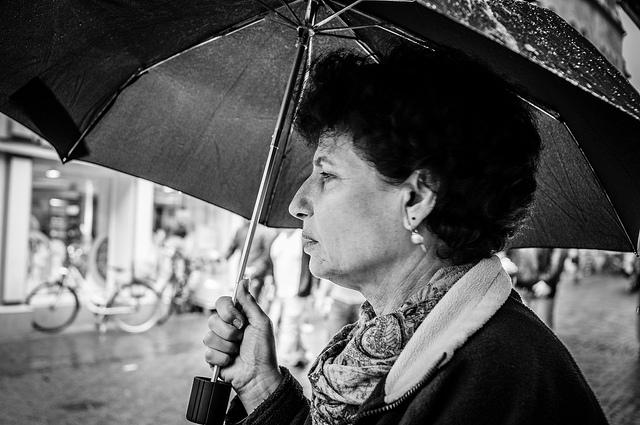What kind of weather is the woman experiencing?

Choices:
A) snow
B) rain
C) sleet
D) wind rain 